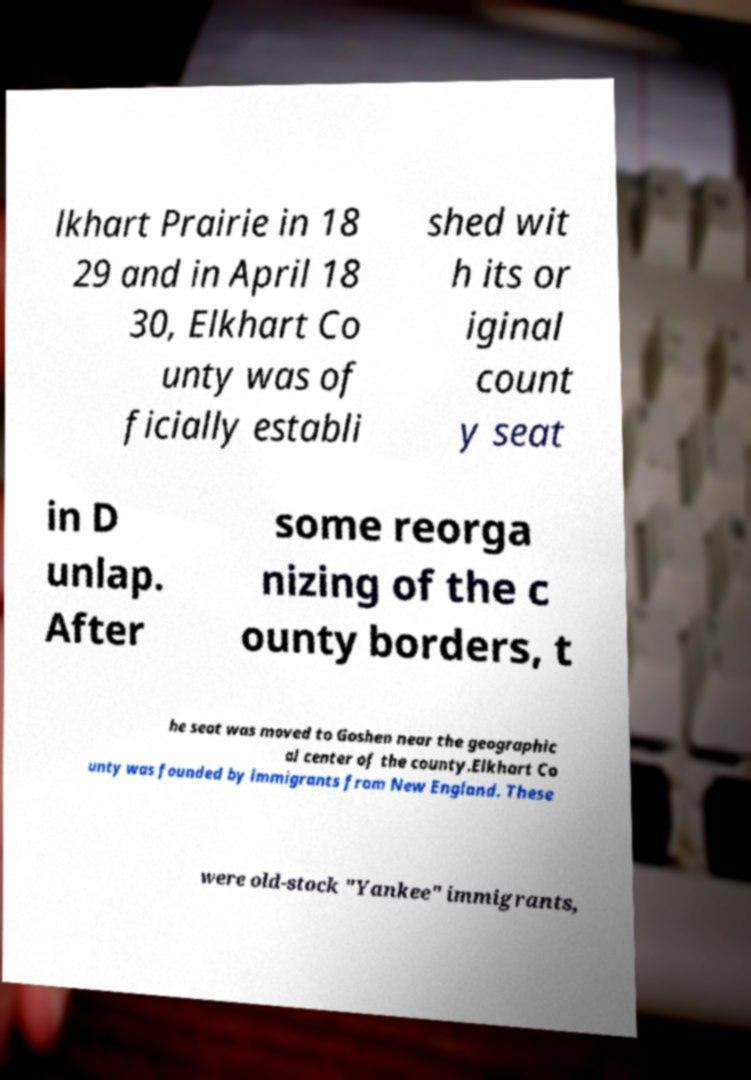Can you read and provide the text displayed in the image?This photo seems to have some interesting text. Can you extract and type it out for me? lkhart Prairie in 18 29 and in April 18 30, Elkhart Co unty was of ficially establi shed wit h its or iginal count y seat in D unlap. After some reorga nizing of the c ounty borders, t he seat was moved to Goshen near the geographic al center of the county.Elkhart Co unty was founded by immigrants from New England. These were old-stock "Yankee" immigrants, 